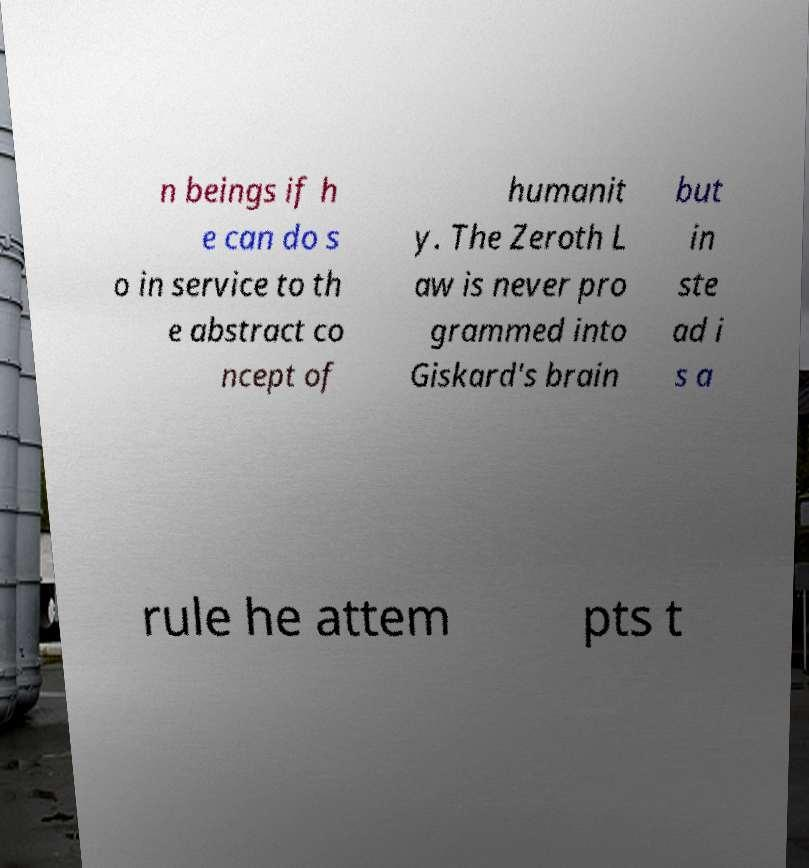Could you extract and type out the text from this image? n beings if h e can do s o in service to th e abstract co ncept of humanit y. The Zeroth L aw is never pro grammed into Giskard's brain but in ste ad i s a rule he attem pts t 